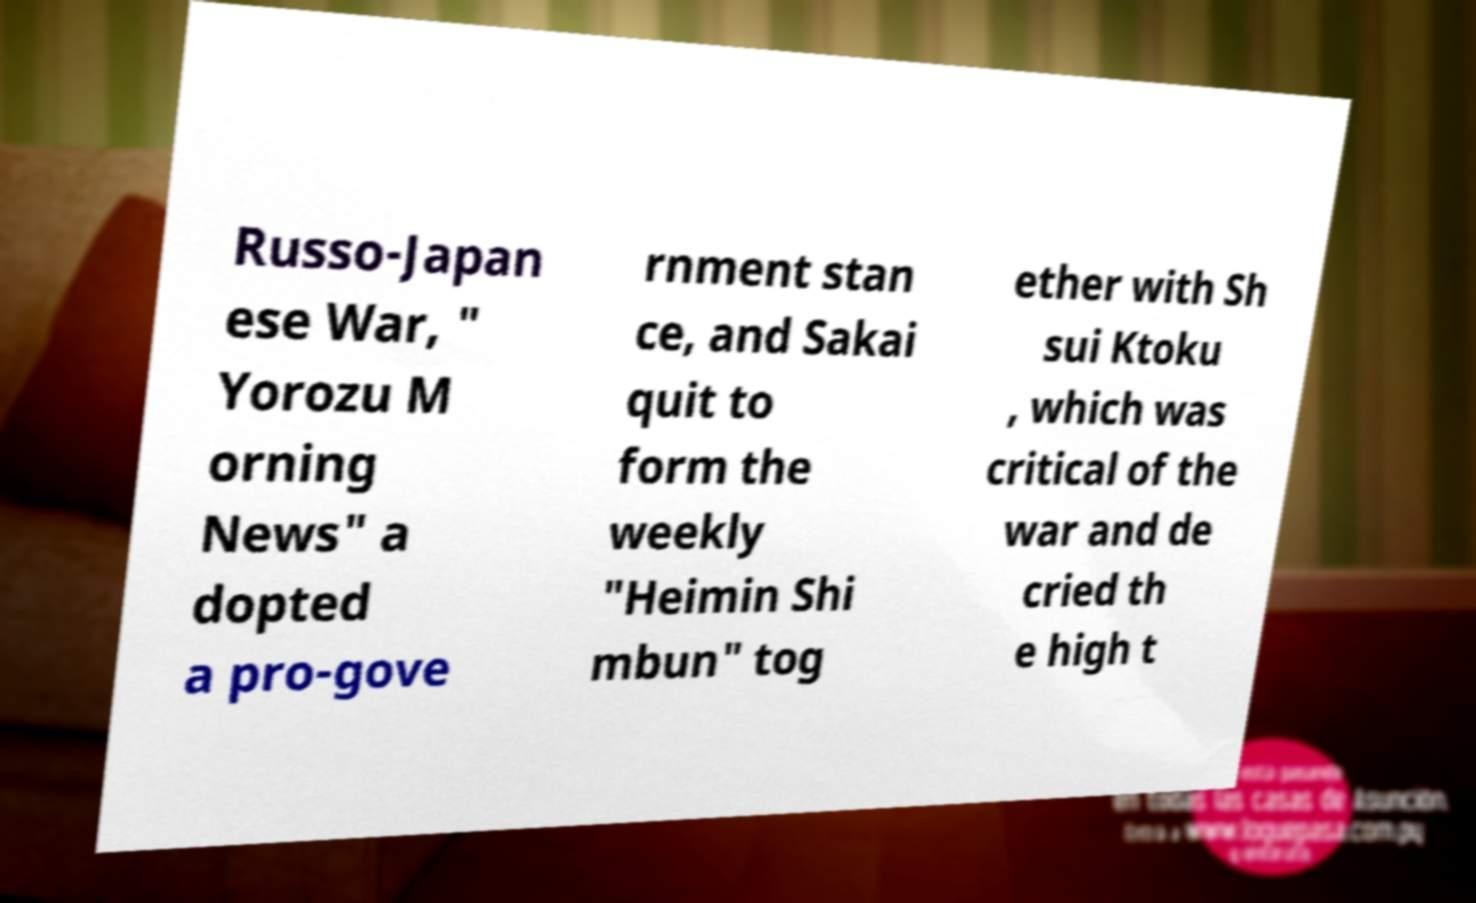For documentation purposes, I need the text within this image transcribed. Could you provide that? Russo-Japan ese War, " Yorozu M orning News" a dopted a pro-gove rnment stan ce, and Sakai quit to form the weekly "Heimin Shi mbun" tog ether with Sh sui Ktoku , which was critical of the war and de cried th e high t 